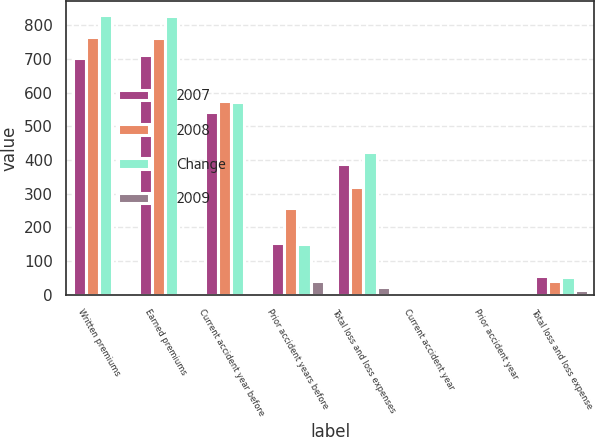<chart> <loc_0><loc_0><loc_500><loc_500><stacked_bar_chart><ecel><fcel>Written premiums<fcel>Earned premiums<fcel>Current accident year before<fcel>Prior accident years before<fcel>Total loss and loss expenses<fcel>Current accident year<fcel>Prior accident year<fcel>Total loss and loss expense<nl><fcel>2007<fcel>704<fcel>712<fcel>542<fcel>154<fcel>388<fcel>0<fcel>0<fcel>54.6<nl><fcel>2008<fcel>764<fcel>763<fcel>576<fcel>257<fcel>319<fcel>0<fcel>0<fcel>41.7<nl><fcel>Change<fcel>830<fcel>827<fcel>572<fcel>149<fcel>423<fcel>0<fcel>0<fcel>51.1<nl><fcel>2009<fcel>7.9<fcel>6.7<fcel>5.9<fcel>40.3<fcel>22<fcel>0<fcel>0<fcel>12.9<nl></chart> 